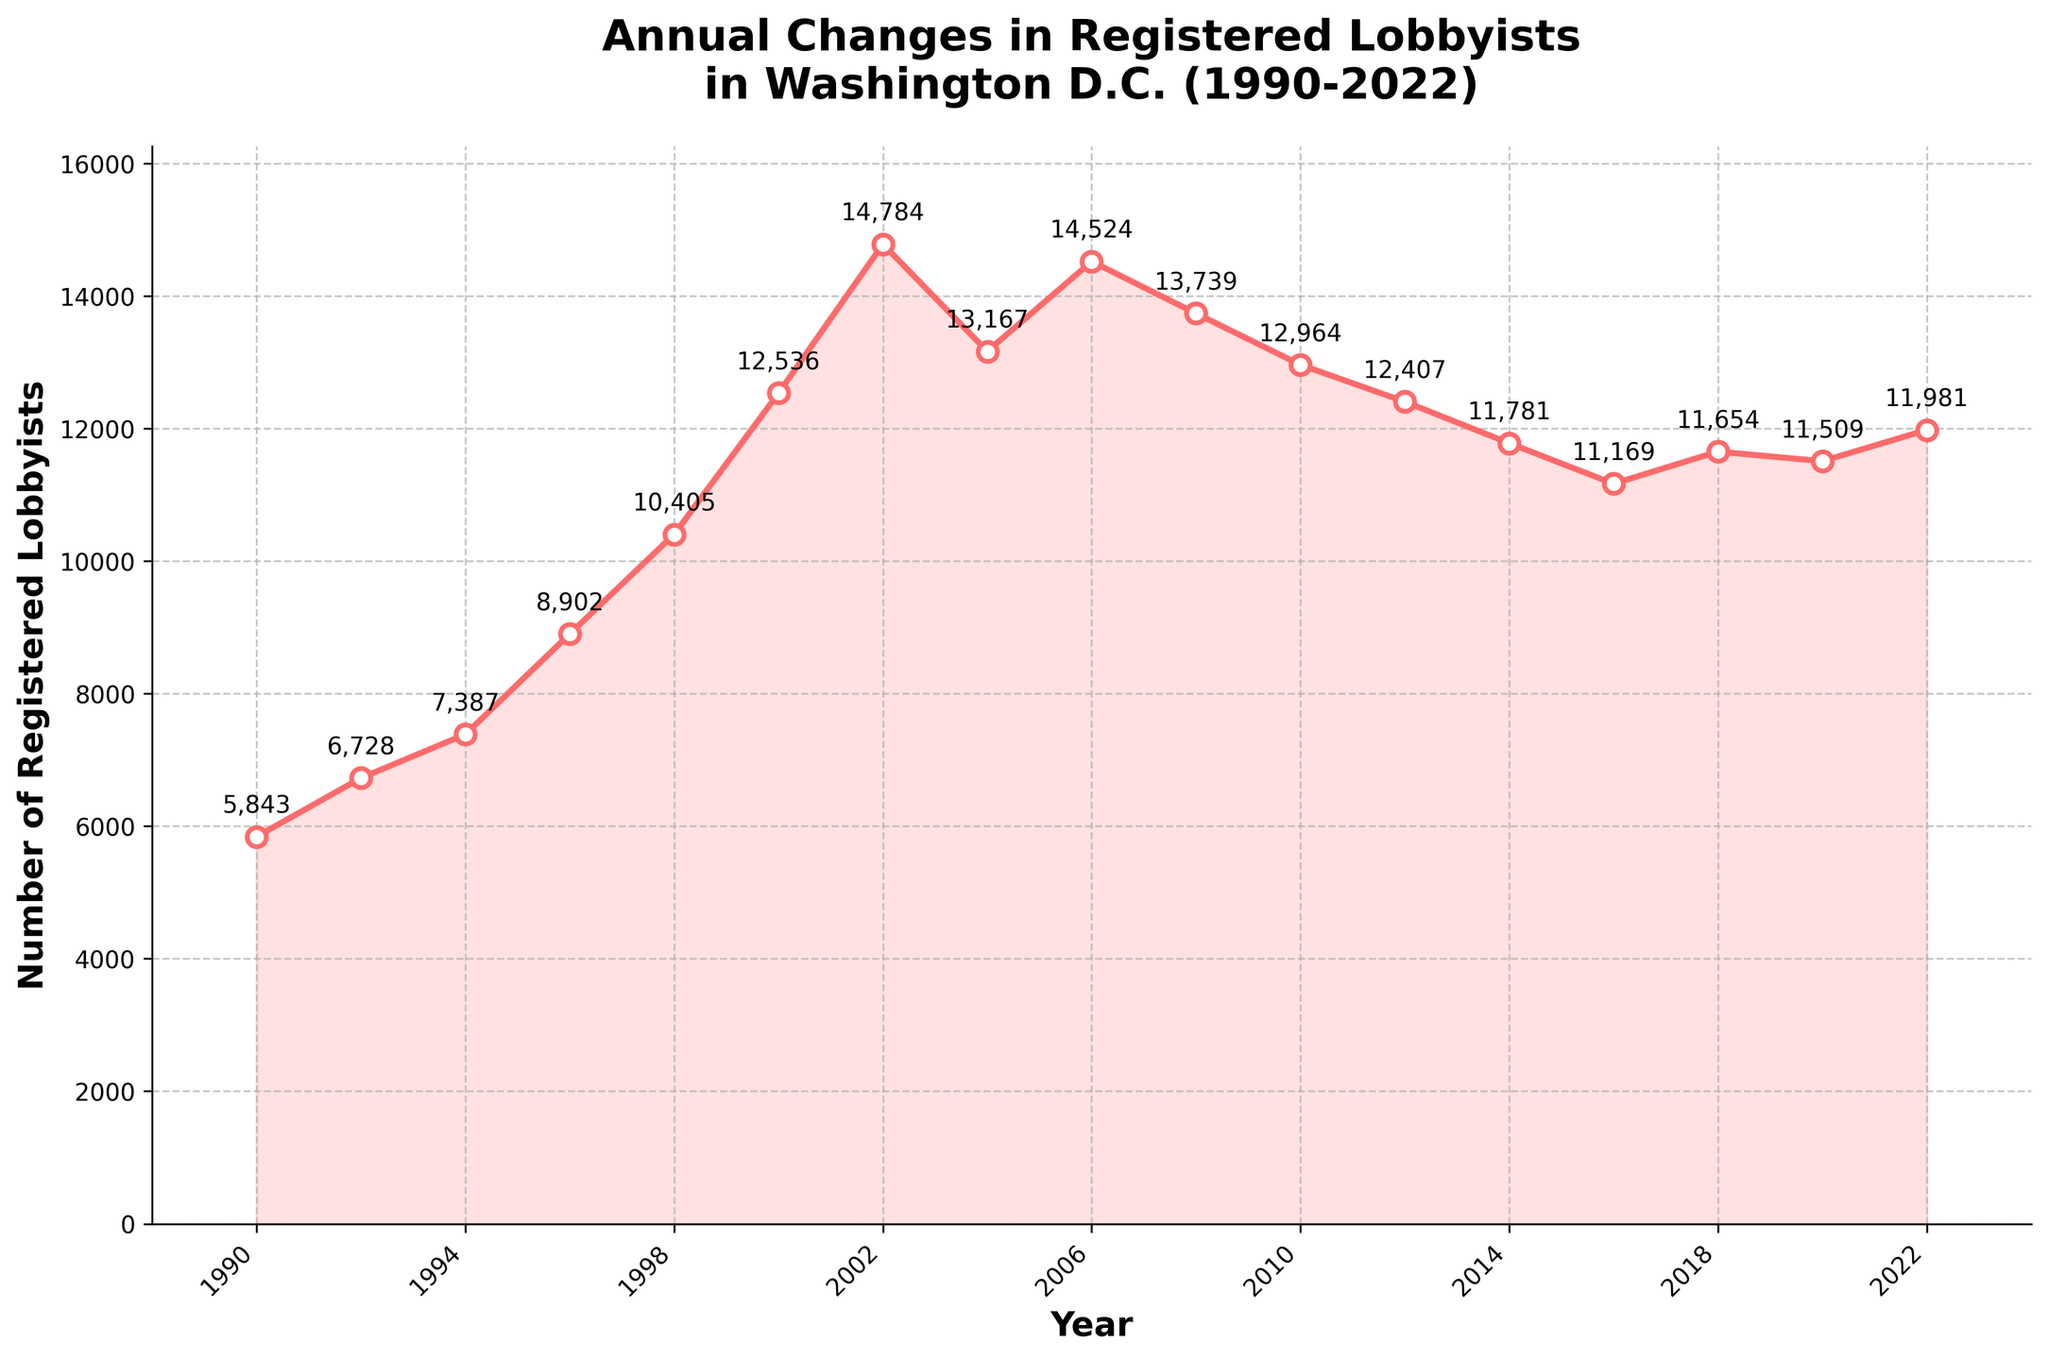What is the highest number of registered lobbyists recorded in the plot? The highest number can be found by identifying the tallest peak on the plotted line. The number at the peak is 14,784 in 2002.
Answer: 14,784 In which year did the number of registered lobbyists first exceed 10,000? The plot shows a sharp rise, and we can see that the first year the count exceeds 10,000 is 1998.
Answer: 1998 How does the number of registered lobbyists in 2022 compare to that in 2000? To compare, locate the data points for both years on the plot. In 2000, the count is 12,536, and in 2022, it is 11,981, showing a decrease.
Answer: Decreased Between which consecutive years did the number of registered lobbyists show the most significant increase? To find this, examine the steepest positive slope between two consecutive data points. The most considerable increase is between 1998 (10,405) and 2000 (12,536), an increase of 2,131.
Answer: 1998-2000 What is the trend in the number of registered lobbyists from 2010 to 2016? Observing the line segment between these years, we see a decreasing trend from 12,964 in 2010 to 11,169 in 2016.
Answer: Decreasing What is the approximate average number of registered lobbyists from 1990 to 2022? Calculate the sum of all registered lobbyists per year and divide by the number of years. Sum = 192,487, Years = 17, so average = 192,487 / 17 ≈ 11,322.
Answer: 11,322 Which year had the lowest number of registered lobbyists, and what was that number? Look for the point at the lowest dip on the plot. The lowest number is in 2016, with 11,169 lobbyists.
Answer: 2016, 11,169 What visual trend is noticeable in the plot from 2002 to 2014? The visual trend shows an increase to a peak in 2002, followed by a steady decline until 2014.
Answer: Increase then decrease Compare the number of registered lobbyists in 1990 and 2022 – by what percentage did it change? ((Number in 2022 - Number in 1990) / Number in 1990) * 100. ((11,981 - 5,843) / 5,843) * 100 ≈ 105.1%.
Answer: 105.1% increase How many times did the number of lobbyists cross below 12,000 after peaking in 2002? After 2002, find each point where the number dips below 12,000: 2010, 2012, 2014, 2016, 2018, 2020, and 2022. This occurs 7 times.
Answer: 7 times 